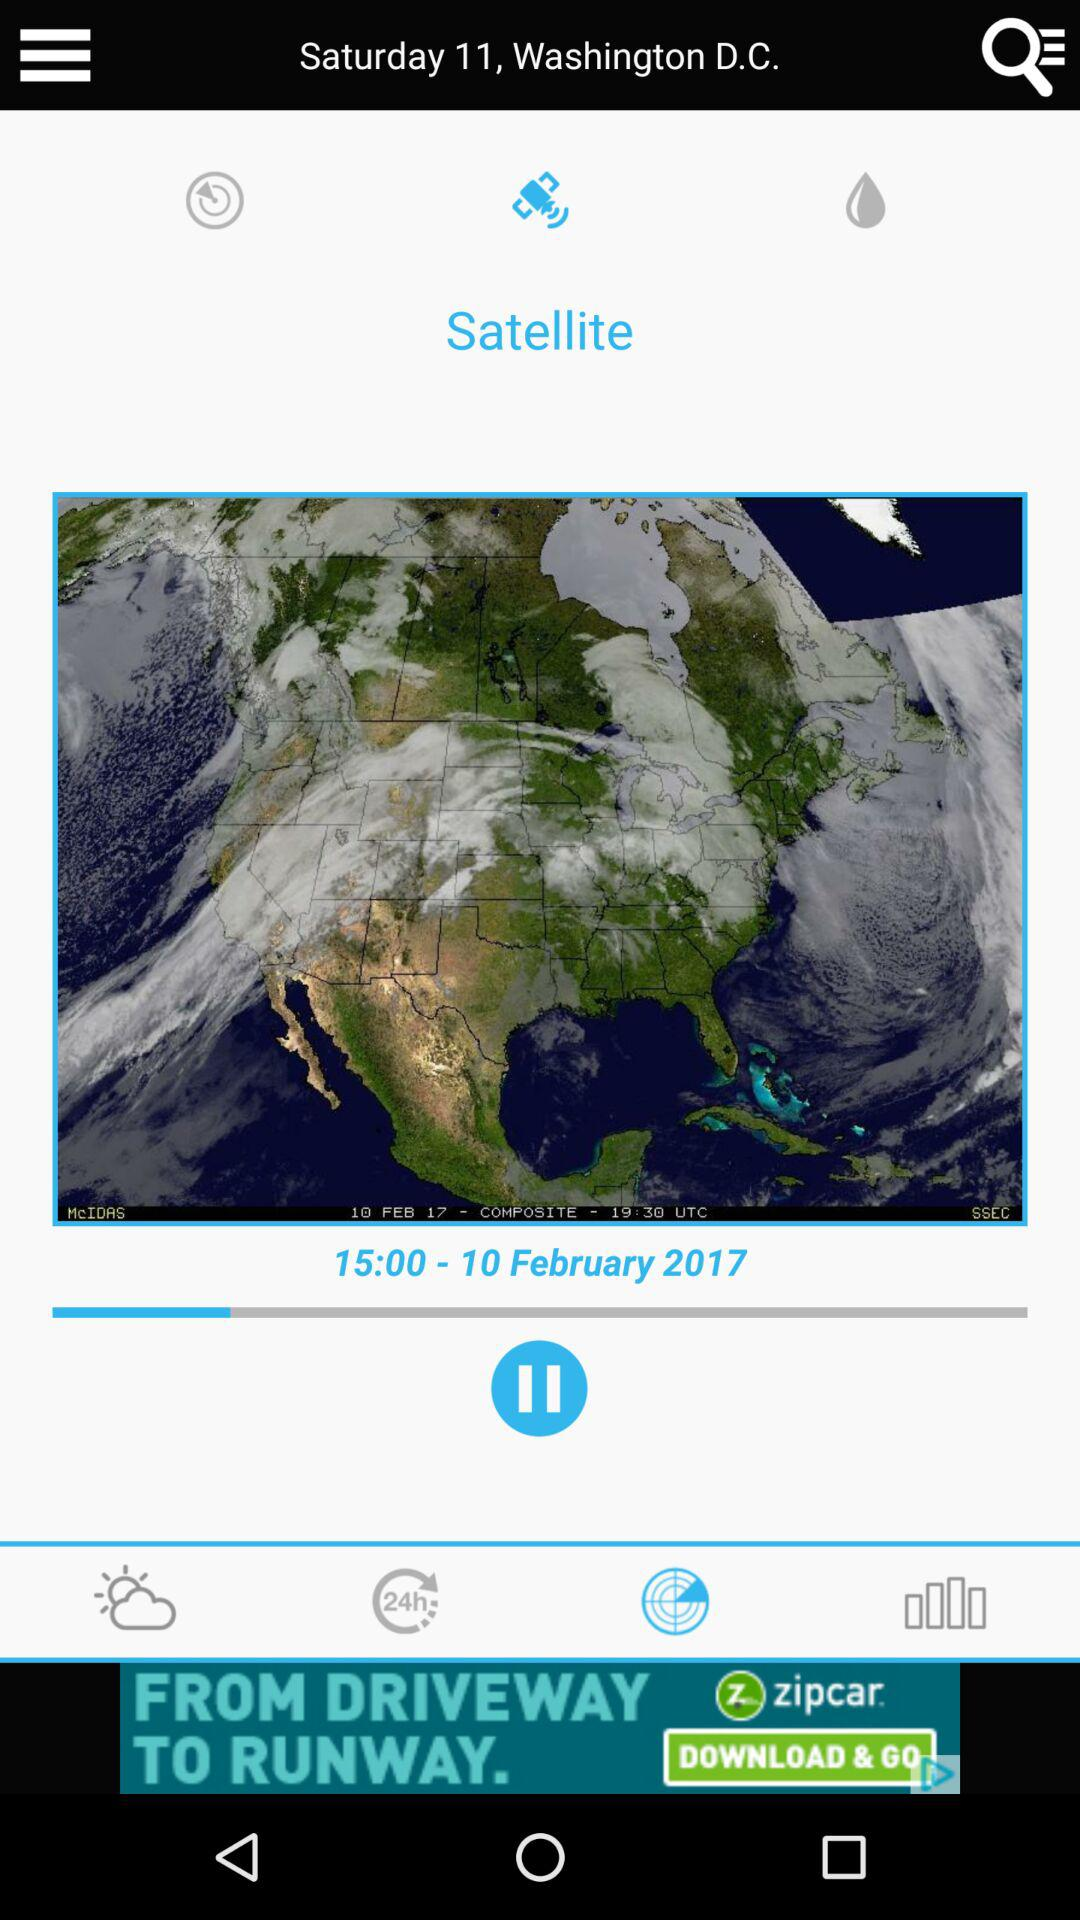What is the location? The location is Washington, D.C. 